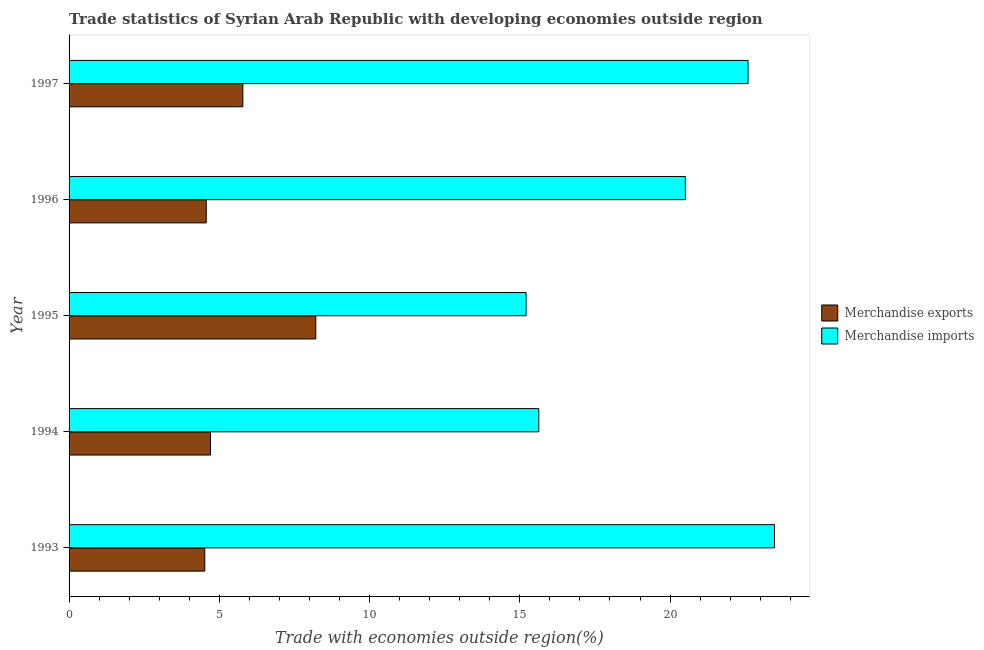Are the number of bars on each tick of the Y-axis equal?
Offer a terse response. Yes. In how many cases, is the number of bars for a given year not equal to the number of legend labels?
Provide a succinct answer. 0. What is the merchandise exports in 1995?
Your answer should be very brief. 8.21. Across all years, what is the maximum merchandise imports?
Your answer should be very brief. 23.47. Across all years, what is the minimum merchandise imports?
Your answer should be compact. 15.21. In which year was the merchandise imports minimum?
Make the answer very short. 1995. What is the total merchandise exports in the graph?
Give a very brief answer. 27.78. What is the difference between the merchandise exports in 1994 and that in 1997?
Offer a terse response. -1.08. What is the difference between the merchandise imports in 1995 and the merchandise exports in 1994?
Offer a very short reply. 10.5. What is the average merchandise exports per year?
Keep it short and to the point. 5.56. In the year 1997, what is the difference between the merchandise imports and merchandise exports?
Offer a terse response. 16.81. What is the ratio of the merchandise imports in 1993 to that in 1994?
Make the answer very short. 1.5. Is the merchandise imports in 1993 less than that in 1994?
Your answer should be compact. No. What is the difference between the highest and the second highest merchandise imports?
Your answer should be very brief. 0.88. What is the difference between the highest and the lowest merchandise imports?
Make the answer very short. 8.27. In how many years, is the merchandise imports greater than the average merchandise imports taken over all years?
Provide a short and direct response. 3. Is the sum of the merchandise imports in 1993 and 1996 greater than the maximum merchandise exports across all years?
Offer a very short reply. Yes. What does the 2nd bar from the top in 1995 represents?
Ensure brevity in your answer.  Merchandise exports. How many years are there in the graph?
Your answer should be very brief. 5. Does the graph contain any zero values?
Provide a succinct answer. No. How many legend labels are there?
Keep it short and to the point. 2. How are the legend labels stacked?
Make the answer very short. Vertical. What is the title of the graph?
Offer a very short reply. Trade statistics of Syrian Arab Republic with developing economies outside region. What is the label or title of the X-axis?
Your response must be concise. Trade with economies outside region(%). What is the Trade with economies outside region(%) of Merchandise exports in 1993?
Your response must be concise. 4.52. What is the Trade with economies outside region(%) in Merchandise imports in 1993?
Keep it short and to the point. 23.47. What is the Trade with economies outside region(%) of Merchandise exports in 1994?
Offer a very short reply. 4.71. What is the Trade with economies outside region(%) of Merchandise imports in 1994?
Provide a succinct answer. 15.63. What is the Trade with economies outside region(%) of Merchandise exports in 1995?
Provide a short and direct response. 8.21. What is the Trade with economies outside region(%) in Merchandise imports in 1995?
Your response must be concise. 15.21. What is the Trade with economies outside region(%) of Merchandise exports in 1996?
Make the answer very short. 4.56. What is the Trade with economies outside region(%) of Merchandise imports in 1996?
Offer a very short reply. 20.51. What is the Trade with economies outside region(%) of Merchandise exports in 1997?
Make the answer very short. 5.78. What is the Trade with economies outside region(%) of Merchandise imports in 1997?
Keep it short and to the point. 22.6. Across all years, what is the maximum Trade with economies outside region(%) in Merchandise exports?
Your response must be concise. 8.21. Across all years, what is the maximum Trade with economies outside region(%) of Merchandise imports?
Your answer should be very brief. 23.47. Across all years, what is the minimum Trade with economies outside region(%) of Merchandise exports?
Your response must be concise. 4.52. Across all years, what is the minimum Trade with economies outside region(%) in Merchandise imports?
Your answer should be compact. 15.21. What is the total Trade with economies outside region(%) of Merchandise exports in the graph?
Make the answer very short. 27.78. What is the total Trade with economies outside region(%) in Merchandise imports in the graph?
Your response must be concise. 97.42. What is the difference between the Trade with economies outside region(%) of Merchandise exports in 1993 and that in 1994?
Ensure brevity in your answer.  -0.19. What is the difference between the Trade with economies outside region(%) of Merchandise imports in 1993 and that in 1994?
Offer a very short reply. 7.84. What is the difference between the Trade with economies outside region(%) in Merchandise exports in 1993 and that in 1995?
Make the answer very short. -3.69. What is the difference between the Trade with economies outside region(%) of Merchandise imports in 1993 and that in 1995?
Keep it short and to the point. 8.27. What is the difference between the Trade with economies outside region(%) in Merchandise exports in 1993 and that in 1996?
Provide a succinct answer. -0.05. What is the difference between the Trade with economies outside region(%) of Merchandise imports in 1993 and that in 1996?
Provide a short and direct response. 2.97. What is the difference between the Trade with economies outside region(%) in Merchandise exports in 1993 and that in 1997?
Ensure brevity in your answer.  -1.27. What is the difference between the Trade with economies outside region(%) of Merchandise imports in 1993 and that in 1997?
Provide a short and direct response. 0.88. What is the difference between the Trade with economies outside region(%) in Merchandise exports in 1994 and that in 1995?
Make the answer very short. -3.5. What is the difference between the Trade with economies outside region(%) of Merchandise imports in 1994 and that in 1995?
Provide a short and direct response. 0.42. What is the difference between the Trade with economies outside region(%) of Merchandise exports in 1994 and that in 1996?
Offer a very short reply. 0.14. What is the difference between the Trade with economies outside region(%) in Merchandise imports in 1994 and that in 1996?
Give a very brief answer. -4.88. What is the difference between the Trade with economies outside region(%) in Merchandise exports in 1994 and that in 1997?
Give a very brief answer. -1.08. What is the difference between the Trade with economies outside region(%) of Merchandise imports in 1994 and that in 1997?
Your response must be concise. -6.96. What is the difference between the Trade with economies outside region(%) of Merchandise exports in 1995 and that in 1996?
Provide a short and direct response. 3.65. What is the difference between the Trade with economies outside region(%) in Merchandise imports in 1995 and that in 1996?
Make the answer very short. -5.3. What is the difference between the Trade with economies outside region(%) in Merchandise exports in 1995 and that in 1997?
Give a very brief answer. 2.43. What is the difference between the Trade with economies outside region(%) in Merchandise imports in 1995 and that in 1997?
Offer a terse response. -7.39. What is the difference between the Trade with economies outside region(%) of Merchandise exports in 1996 and that in 1997?
Ensure brevity in your answer.  -1.22. What is the difference between the Trade with economies outside region(%) in Merchandise imports in 1996 and that in 1997?
Your response must be concise. -2.09. What is the difference between the Trade with economies outside region(%) of Merchandise exports in 1993 and the Trade with economies outside region(%) of Merchandise imports in 1994?
Offer a terse response. -11.12. What is the difference between the Trade with economies outside region(%) of Merchandise exports in 1993 and the Trade with economies outside region(%) of Merchandise imports in 1995?
Your response must be concise. -10.69. What is the difference between the Trade with economies outside region(%) of Merchandise exports in 1993 and the Trade with economies outside region(%) of Merchandise imports in 1996?
Ensure brevity in your answer.  -15.99. What is the difference between the Trade with economies outside region(%) of Merchandise exports in 1993 and the Trade with economies outside region(%) of Merchandise imports in 1997?
Offer a terse response. -18.08. What is the difference between the Trade with economies outside region(%) in Merchandise exports in 1994 and the Trade with economies outside region(%) in Merchandise imports in 1995?
Give a very brief answer. -10.5. What is the difference between the Trade with economies outside region(%) in Merchandise exports in 1994 and the Trade with economies outside region(%) in Merchandise imports in 1996?
Provide a succinct answer. -15.8. What is the difference between the Trade with economies outside region(%) of Merchandise exports in 1994 and the Trade with economies outside region(%) of Merchandise imports in 1997?
Provide a succinct answer. -17.89. What is the difference between the Trade with economies outside region(%) in Merchandise exports in 1995 and the Trade with economies outside region(%) in Merchandise imports in 1996?
Offer a very short reply. -12.3. What is the difference between the Trade with economies outside region(%) of Merchandise exports in 1995 and the Trade with economies outside region(%) of Merchandise imports in 1997?
Your answer should be compact. -14.39. What is the difference between the Trade with economies outside region(%) in Merchandise exports in 1996 and the Trade with economies outside region(%) in Merchandise imports in 1997?
Your response must be concise. -18.03. What is the average Trade with economies outside region(%) in Merchandise exports per year?
Give a very brief answer. 5.56. What is the average Trade with economies outside region(%) in Merchandise imports per year?
Ensure brevity in your answer.  19.48. In the year 1993, what is the difference between the Trade with economies outside region(%) of Merchandise exports and Trade with economies outside region(%) of Merchandise imports?
Offer a terse response. -18.96. In the year 1994, what is the difference between the Trade with economies outside region(%) of Merchandise exports and Trade with economies outside region(%) of Merchandise imports?
Offer a very short reply. -10.93. In the year 1995, what is the difference between the Trade with economies outside region(%) of Merchandise exports and Trade with economies outside region(%) of Merchandise imports?
Your answer should be compact. -7. In the year 1996, what is the difference between the Trade with economies outside region(%) in Merchandise exports and Trade with economies outside region(%) in Merchandise imports?
Your response must be concise. -15.95. In the year 1997, what is the difference between the Trade with economies outside region(%) of Merchandise exports and Trade with economies outside region(%) of Merchandise imports?
Your answer should be very brief. -16.81. What is the ratio of the Trade with economies outside region(%) in Merchandise exports in 1993 to that in 1994?
Your answer should be compact. 0.96. What is the ratio of the Trade with economies outside region(%) in Merchandise imports in 1993 to that in 1994?
Provide a short and direct response. 1.5. What is the ratio of the Trade with economies outside region(%) in Merchandise exports in 1993 to that in 1995?
Provide a short and direct response. 0.55. What is the ratio of the Trade with economies outside region(%) in Merchandise imports in 1993 to that in 1995?
Your answer should be very brief. 1.54. What is the ratio of the Trade with economies outside region(%) of Merchandise imports in 1993 to that in 1996?
Your answer should be very brief. 1.14. What is the ratio of the Trade with economies outside region(%) of Merchandise exports in 1993 to that in 1997?
Give a very brief answer. 0.78. What is the ratio of the Trade with economies outside region(%) of Merchandise imports in 1993 to that in 1997?
Your answer should be compact. 1.04. What is the ratio of the Trade with economies outside region(%) of Merchandise exports in 1994 to that in 1995?
Ensure brevity in your answer.  0.57. What is the ratio of the Trade with economies outside region(%) of Merchandise imports in 1994 to that in 1995?
Your answer should be compact. 1.03. What is the ratio of the Trade with economies outside region(%) in Merchandise exports in 1994 to that in 1996?
Offer a very short reply. 1.03. What is the ratio of the Trade with economies outside region(%) in Merchandise imports in 1994 to that in 1996?
Your response must be concise. 0.76. What is the ratio of the Trade with economies outside region(%) of Merchandise exports in 1994 to that in 1997?
Make the answer very short. 0.81. What is the ratio of the Trade with economies outside region(%) in Merchandise imports in 1994 to that in 1997?
Your answer should be very brief. 0.69. What is the ratio of the Trade with economies outside region(%) in Merchandise exports in 1995 to that in 1996?
Your response must be concise. 1.8. What is the ratio of the Trade with economies outside region(%) of Merchandise imports in 1995 to that in 1996?
Your response must be concise. 0.74. What is the ratio of the Trade with economies outside region(%) of Merchandise exports in 1995 to that in 1997?
Your answer should be very brief. 1.42. What is the ratio of the Trade with economies outside region(%) in Merchandise imports in 1995 to that in 1997?
Provide a succinct answer. 0.67. What is the ratio of the Trade with economies outside region(%) in Merchandise exports in 1996 to that in 1997?
Your answer should be compact. 0.79. What is the ratio of the Trade with economies outside region(%) in Merchandise imports in 1996 to that in 1997?
Offer a terse response. 0.91. What is the difference between the highest and the second highest Trade with economies outside region(%) of Merchandise exports?
Make the answer very short. 2.43. What is the difference between the highest and the second highest Trade with economies outside region(%) of Merchandise imports?
Give a very brief answer. 0.88. What is the difference between the highest and the lowest Trade with economies outside region(%) in Merchandise exports?
Ensure brevity in your answer.  3.69. What is the difference between the highest and the lowest Trade with economies outside region(%) in Merchandise imports?
Provide a short and direct response. 8.27. 